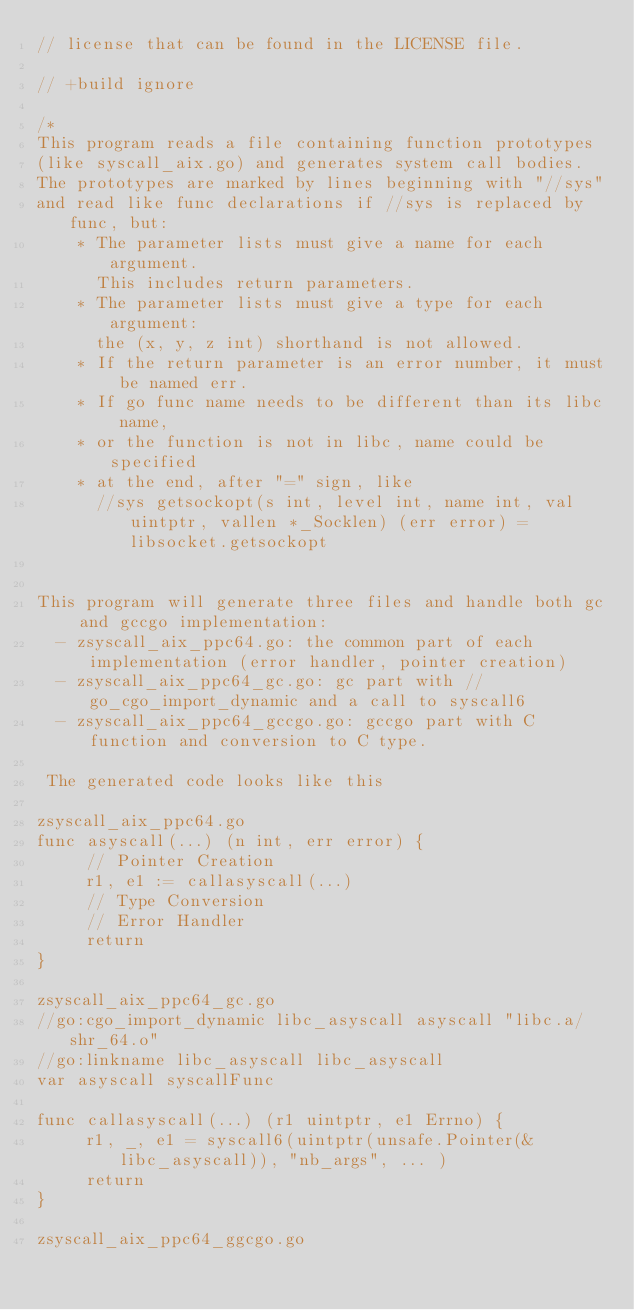<code> <loc_0><loc_0><loc_500><loc_500><_Go_>// license that can be found in the LICENSE file.

// +build ignore

/*
This program reads a file containing function prototypes
(like syscall_aix.go) and generates system call bodies.
The prototypes are marked by lines beginning with "//sys"
and read like func declarations if //sys is replaced by func, but:
	* The parameter lists must give a name for each argument.
	  This includes return parameters.
	* The parameter lists must give a type for each argument:
	  the (x, y, z int) shorthand is not allowed.
	* If the return parameter is an error number, it must be named err.
	* If go func name needs to be different than its libc name,
	* or the function is not in libc, name could be specified
	* at the end, after "=" sign, like
	  //sys getsockopt(s int, level int, name int, val uintptr, vallen *_Socklen) (err error) = libsocket.getsockopt


This program will generate three files and handle both gc and gccgo implementation:
  - zsyscall_aix_ppc64.go: the common part of each implementation (error handler, pointer creation)
  - zsyscall_aix_ppc64_gc.go: gc part with //go_cgo_import_dynamic and a call to syscall6
  - zsyscall_aix_ppc64_gccgo.go: gccgo part with C function and conversion to C type.

 The generated code looks like this

zsyscall_aix_ppc64.go
func asyscall(...) (n int, err error) {
	 // Pointer Creation
	 r1, e1 := callasyscall(...)
	 // Type Conversion
	 // Error Handler
	 return
}

zsyscall_aix_ppc64_gc.go
//go:cgo_import_dynamic libc_asyscall asyscall "libc.a/shr_64.o"
//go:linkname libc_asyscall libc_asyscall
var asyscall syscallFunc

func callasyscall(...) (r1 uintptr, e1 Errno) {
	 r1, _, e1 = syscall6(uintptr(unsafe.Pointer(&libc_asyscall)), "nb_args", ... )
	 return
}

zsyscall_aix_ppc64_ggcgo.go
</code> 